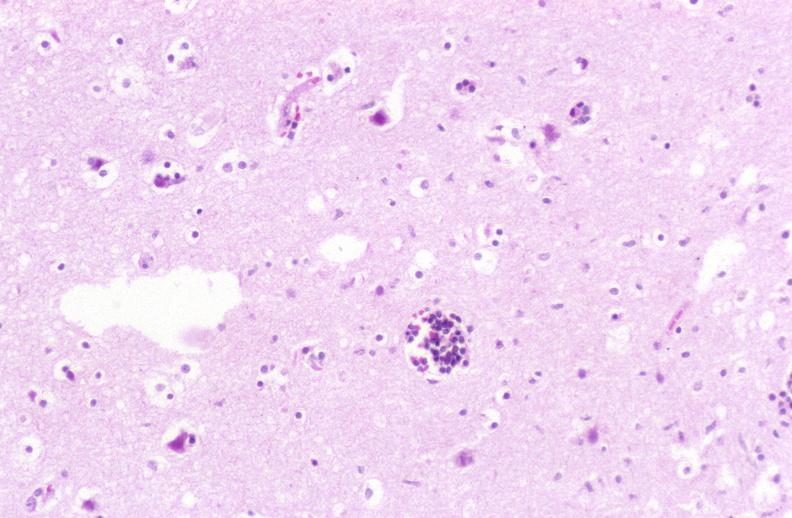s marked present?
Answer the question using a single word or phrase. No 